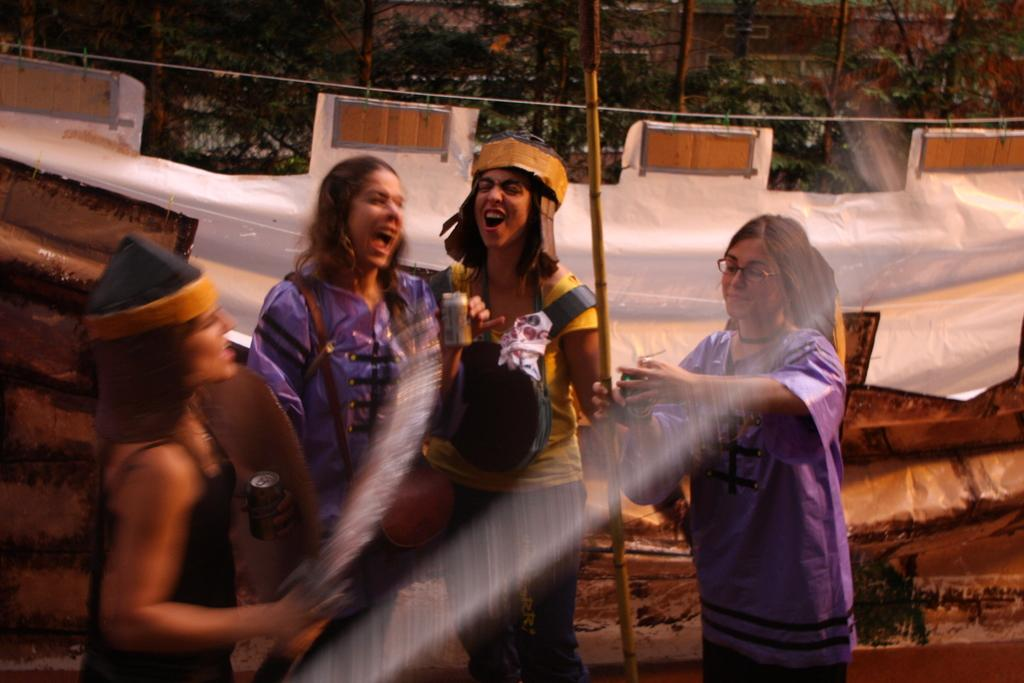Who is present in the image? There are women in the image. What can be seen in the background of the image? There are trees and a cable in the background of the image. What is visible in the image besides the women? Water is visible in the image. What type of farming equipment can be seen in the image? There is no farming equipment present in the image. 